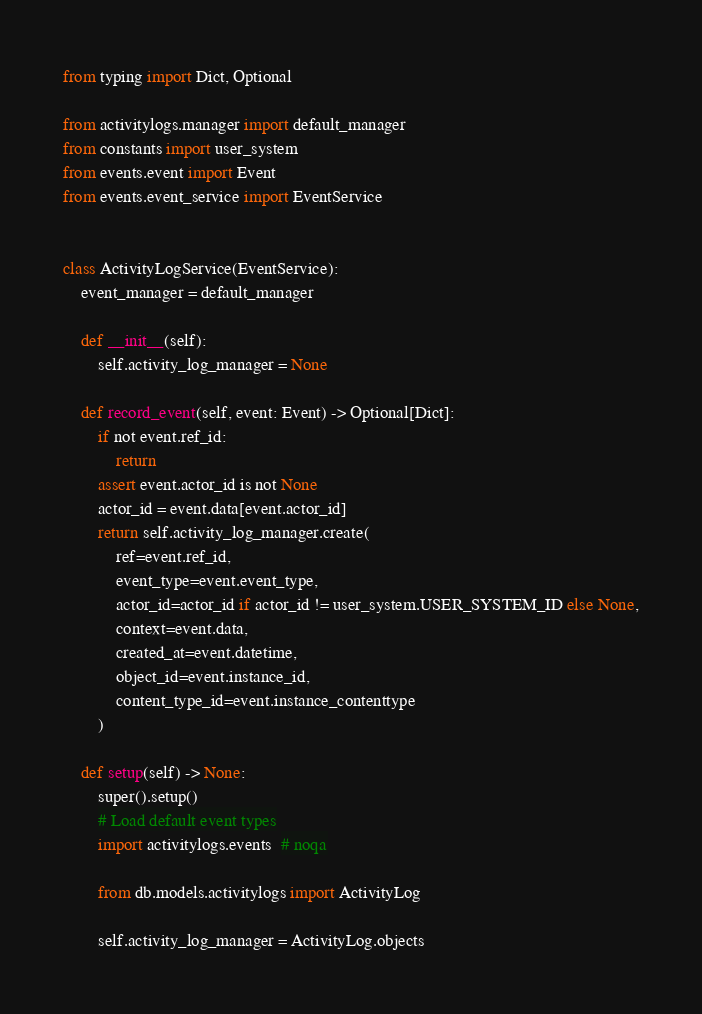<code> <loc_0><loc_0><loc_500><loc_500><_Python_>from typing import Dict, Optional

from activitylogs.manager import default_manager
from constants import user_system
from events.event import Event
from events.event_service import EventService


class ActivityLogService(EventService):
    event_manager = default_manager

    def __init__(self):
        self.activity_log_manager = None

    def record_event(self, event: Event) -> Optional[Dict]:
        if not event.ref_id:
            return
        assert event.actor_id is not None
        actor_id = event.data[event.actor_id]
        return self.activity_log_manager.create(
            ref=event.ref_id,
            event_type=event.event_type,
            actor_id=actor_id if actor_id != user_system.USER_SYSTEM_ID else None,
            context=event.data,
            created_at=event.datetime,
            object_id=event.instance_id,
            content_type_id=event.instance_contenttype
        )

    def setup(self) -> None:
        super().setup()
        # Load default event types
        import activitylogs.events  # noqa

        from db.models.activitylogs import ActivityLog

        self.activity_log_manager = ActivityLog.objects
</code> 